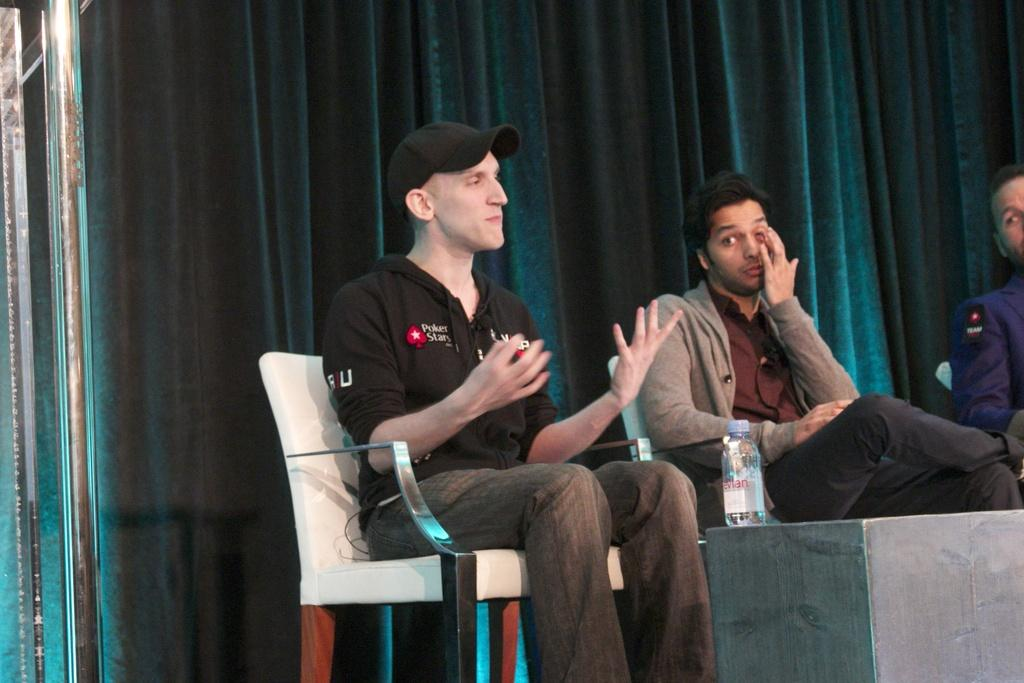What can be seen in the foreground of the picture? In the foreground of the picture, there are people, chairs, a table, and a bottle. What objects are present near the people in the picture? The people are near chairs and a table in the foreground of the picture. What is on the left side of the picture? There are iron poles on the left side of the picture. What can be seen in the background of the picture? There is a green colored curtain in the background of the picture. What language is being spoken by the people in the picture? The provided facts do not mention any specific language being spoken by the people in the picture. Is there a river visible in the picture? There is no mention of a river in the provided facts, so it cannot be determined if one is present in the image. 